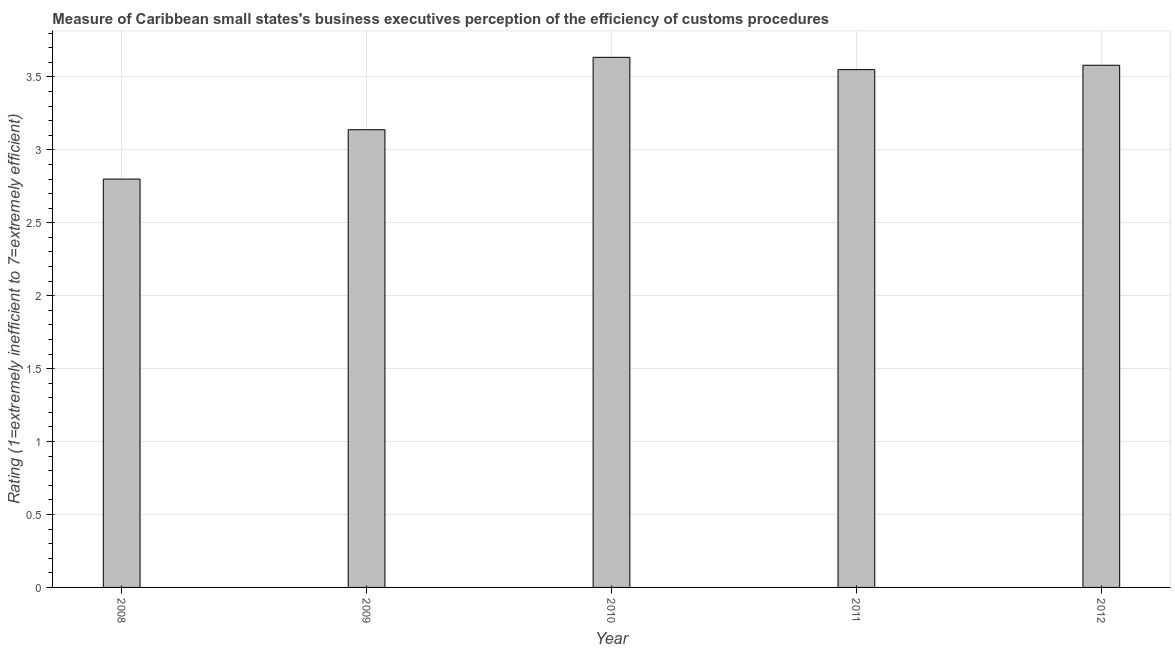Does the graph contain any zero values?
Keep it short and to the point. No. What is the title of the graph?
Provide a short and direct response. Measure of Caribbean small states's business executives perception of the efficiency of customs procedures. What is the label or title of the X-axis?
Provide a short and direct response. Year. What is the label or title of the Y-axis?
Provide a succinct answer. Rating (1=extremely inefficient to 7=extremely efficient). What is the rating measuring burden of customs procedure in 2012?
Provide a short and direct response. 3.58. Across all years, what is the maximum rating measuring burden of customs procedure?
Offer a very short reply. 3.63. Across all years, what is the minimum rating measuring burden of customs procedure?
Keep it short and to the point. 2.8. In which year was the rating measuring burden of customs procedure maximum?
Provide a short and direct response. 2010. In which year was the rating measuring burden of customs procedure minimum?
Make the answer very short. 2008. What is the sum of the rating measuring burden of customs procedure?
Offer a terse response. 16.7. What is the difference between the rating measuring burden of customs procedure in 2009 and 2011?
Your answer should be compact. -0.41. What is the average rating measuring burden of customs procedure per year?
Your answer should be compact. 3.34. What is the median rating measuring burden of customs procedure?
Give a very brief answer. 3.55. Do a majority of the years between 2009 and 2010 (inclusive) have rating measuring burden of customs procedure greater than 3 ?
Give a very brief answer. Yes. What is the ratio of the rating measuring burden of customs procedure in 2008 to that in 2012?
Provide a short and direct response. 0.78. Is the rating measuring burden of customs procedure in 2010 less than that in 2011?
Your response must be concise. No. Is the difference between the rating measuring burden of customs procedure in 2008 and 2012 greater than the difference between any two years?
Your answer should be very brief. No. What is the difference between the highest and the second highest rating measuring burden of customs procedure?
Your answer should be very brief. 0.05. Is the sum of the rating measuring burden of customs procedure in 2011 and 2012 greater than the maximum rating measuring burden of customs procedure across all years?
Offer a very short reply. Yes. What is the difference between the highest and the lowest rating measuring burden of customs procedure?
Provide a succinct answer. 0.83. In how many years, is the rating measuring burden of customs procedure greater than the average rating measuring burden of customs procedure taken over all years?
Your answer should be compact. 3. Are the values on the major ticks of Y-axis written in scientific E-notation?
Your answer should be very brief. No. What is the Rating (1=extremely inefficient to 7=extremely efficient) in 2008?
Offer a terse response. 2.8. What is the Rating (1=extremely inefficient to 7=extremely efficient) in 2009?
Give a very brief answer. 3.14. What is the Rating (1=extremely inefficient to 7=extremely efficient) in 2010?
Provide a short and direct response. 3.63. What is the Rating (1=extremely inefficient to 7=extremely efficient) in 2011?
Ensure brevity in your answer.  3.55. What is the Rating (1=extremely inefficient to 7=extremely efficient) in 2012?
Your response must be concise. 3.58. What is the difference between the Rating (1=extremely inefficient to 7=extremely efficient) in 2008 and 2009?
Give a very brief answer. -0.34. What is the difference between the Rating (1=extremely inefficient to 7=extremely efficient) in 2008 and 2010?
Make the answer very short. -0.83. What is the difference between the Rating (1=extremely inefficient to 7=extremely efficient) in 2008 and 2011?
Your response must be concise. -0.75. What is the difference between the Rating (1=extremely inefficient to 7=extremely efficient) in 2008 and 2012?
Your response must be concise. -0.78. What is the difference between the Rating (1=extremely inefficient to 7=extremely efficient) in 2009 and 2010?
Offer a terse response. -0.5. What is the difference between the Rating (1=extremely inefficient to 7=extremely efficient) in 2009 and 2011?
Your answer should be very brief. -0.41. What is the difference between the Rating (1=extremely inefficient to 7=extremely efficient) in 2009 and 2012?
Provide a short and direct response. -0.44. What is the difference between the Rating (1=extremely inefficient to 7=extremely efficient) in 2010 and 2011?
Ensure brevity in your answer.  0.08. What is the difference between the Rating (1=extremely inefficient to 7=extremely efficient) in 2010 and 2012?
Provide a succinct answer. 0.05. What is the difference between the Rating (1=extremely inefficient to 7=extremely efficient) in 2011 and 2012?
Provide a succinct answer. -0.03. What is the ratio of the Rating (1=extremely inefficient to 7=extremely efficient) in 2008 to that in 2009?
Your response must be concise. 0.89. What is the ratio of the Rating (1=extremely inefficient to 7=extremely efficient) in 2008 to that in 2010?
Provide a succinct answer. 0.77. What is the ratio of the Rating (1=extremely inefficient to 7=extremely efficient) in 2008 to that in 2011?
Your response must be concise. 0.79. What is the ratio of the Rating (1=extremely inefficient to 7=extremely efficient) in 2008 to that in 2012?
Your answer should be very brief. 0.78. What is the ratio of the Rating (1=extremely inefficient to 7=extremely efficient) in 2009 to that in 2010?
Ensure brevity in your answer.  0.86. What is the ratio of the Rating (1=extremely inefficient to 7=extremely efficient) in 2009 to that in 2011?
Offer a terse response. 0.88. What is the ratio of the Rating (1=extremely inefficient to 7=extremely efficient) in 2009 to that in 2012?
Ensure brevity in your answer.  0.88. What is the ratio of the Rating (1=extremely inefficient to 7=extremely efficient) in 2010 to that in 2011?
Ensure brevity in your answer.  1.02. What is the ratio of the Rating (1=extremely inefficient to 7=extremely efficient) in 2010 to that in 2012?
Your answer should be very brief. 1.01. 